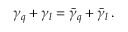<formula> <loc_0><loc_0><loc_500><loc_500>\gamma _ { q } + \gamma _ { l } = \bar { \gamma } _ { q } + \bar { \gamma } _ { l } \, .</formula> 